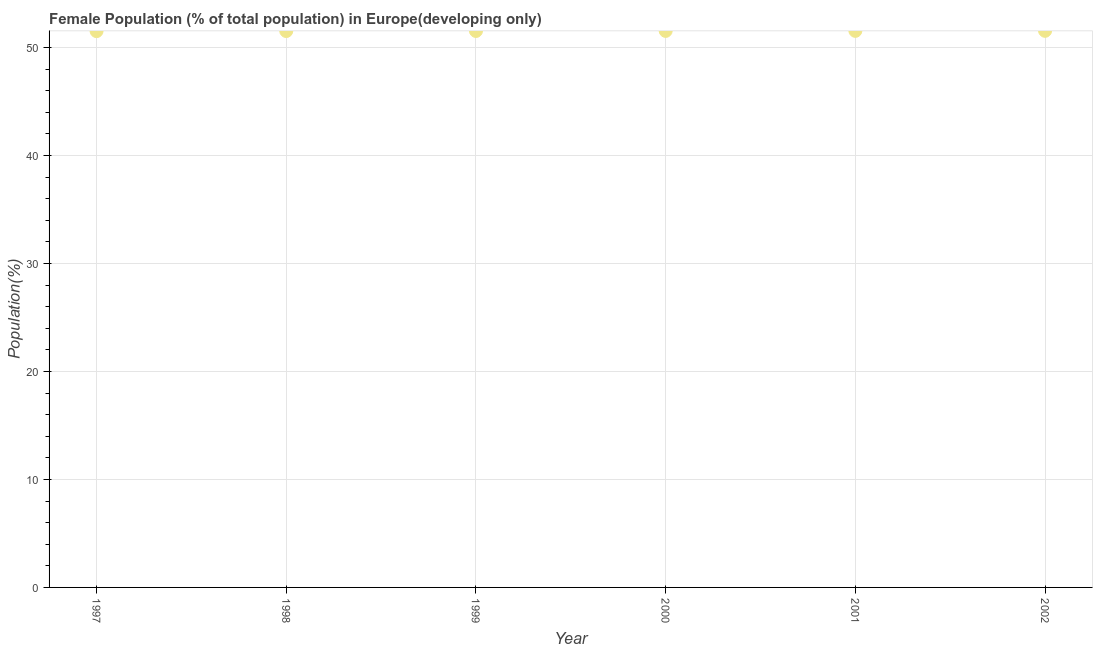What is the female population in 2000?
Offer a terse response. 51.55. Across all years, what is the maximum female population?
Ensure brevity in your answer.  51.55. Across all years, what is the minimum female population?
Give a very brief answer. 51.53. In which year was the female population minimum?
Keep it short and to the point. 1997. What is the sum of the female population?
Provide a short and direct response. 309.25. What is the difference between the female population in 1997 and 2001?
Offer a very short reply. -0.02. What is the average female population per year?
Your response must be concise. 51.54. What is the median female population?
Your answer should be compact. 51.54. Do a majority of the years between 2001 and 1997 (inclusive) have female population greater than 2 %?
Your answer should be very brief. Yes. What is the ratio of the female population in 1998 to that in 2000?
Offer a terse response. 1. Is the female population in 1997 less than that in 1998?
Your answer should be very brief. Yes. What is the difference between the highest and the second highest female population?
Ensure brevity in your answer.  0. What is the difference between the highest and the lowest female population?
Offer a terse response. 0.03. How many dotlines are there?
Provide a succinct answer. 1. How many years are there in the graph?
Your answer should be very brief. 6. Does the graph contain grids?
Provide a succinct answer. Yes. What is the title of the graph?
Offer a terse response. Female Population (% of total population) in Europe(developing only). What is the label or title of the Y-axis?
Your response must be concise. Population(%). What is the Population(%) in 1997?
Make the answer very short. 51.53. What is the Population(%) in 1998?
Your answer should be very brief. 51.53. What is the Population(%) in 1999?
Your response must be concise. 51.54. What is the Population(%) in 2000?
Offer a terse response. 51.55. What is the Population(%) in 2001?
Ensure brevity in your answer.  51.55. What is the Population(%) in 2002?
Make the answer very short. 51.55. What is the difference between the Population(%) in 1997 and 1998?
Your response must be concise. -0.01. What is the difference between the Population(%) in 1997 and 1999?
Give a very brief answer. -0.01. What is the difference between the Population(%) in 1997 and 2000?
Offer a terse response. -0.02. What is the difference between the Population(%) in 1997 and 2001?
Provide a succinct answer. -0.02. What is the difference between the Population(%) in 1997 and 2002?
Your answer should be very brief. -0.03. What is the difference between the Population(%) in 1998 and 1999?
Ensure brevity in your answer.  -0.01. What is the difference between the Population(%) in 1998 and 2000?
Your response must be concise. -0.01. What is the difference between the Population(%) in 1998 and 2001?
Make the answer very short. -0.02. What is the difference between the Population(%) in 1998 and 2002?
Your response must be concise. -0.02. What is the difference between the Population(%) in 1999 and 2000?
Keep it short and to the point. -0.01. What is the difference between the Population(%) in 1999 and 2001?
Offer a terse response. -0.01. What is the difference between the Population(%) in 1999 and 2002?
Keep it short and to the point. -0.01. What is the difference between the Population(%) in 2000 and 2001?
Make the answer very short. -0. What is the difference between the Population(%) in 2000 and 2002?
Your answer should be compact. -0.01. What is the difference between the Population(%) in 2001 and 2002?
Offer a very short reply. -0. What is the ratio of the Population(%) in 1997 to that in 1999?
Ensure brevity in your answer.  1. What is the ratio of the Population(%) in 1998 to that in 2000?
Your answer should be very brief. 1. What is the ratio of the Population(%) in 1999 to that in 2002?
Your answer should be compact. 1. 